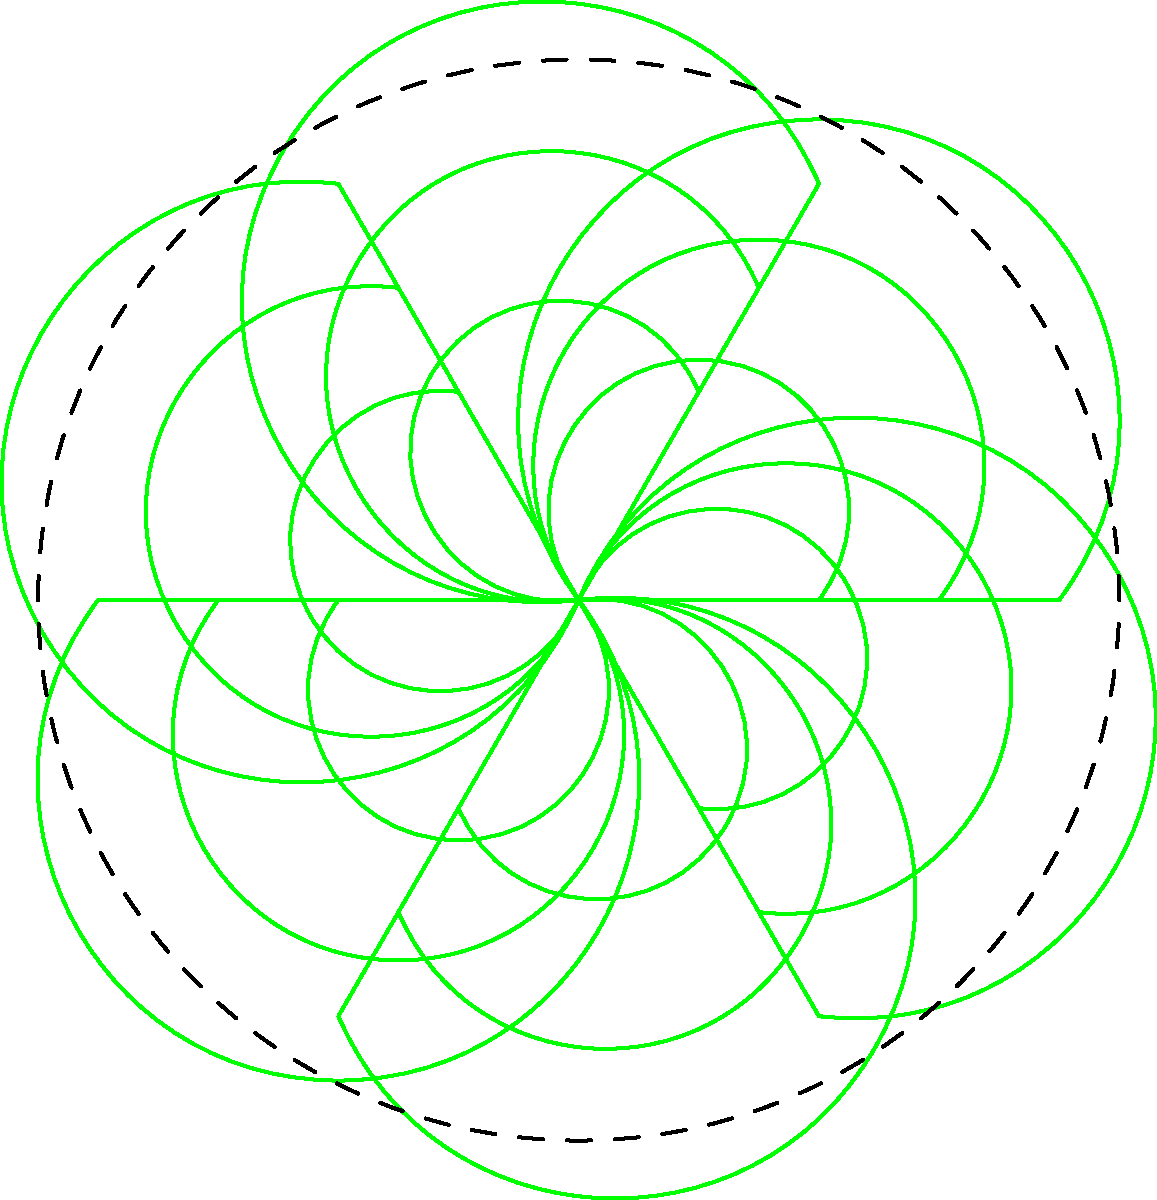In creating a mandala-like pattern for a yoga studio logo using a simple leaf shape, you apply the following transformations: rotation by 60° around the origin, repeated 6 times, and scaling by factors of 1.5 and 2 for each rotated leaf. How many total leaf shapes are in the final pattern? Let's break down the transformations and count the leaf shapes step-by-step:

1. Initial rotation:
   - The leaf shape is rotated 60° around the origin, repeated 6 times.
   - This creates 6 leaf shapes in the innermost ring.

2. Scaling for each rotated leaf:
   - For each of the 6 rotated leaves, two additional scaled versions are created:
     a) Scaled by a factor of 1.5
     b) Scaled by a factor of 2
   - This means for each of the 6 rotated leaves, we have 2 additional leaves.

3. Counting the total leaves:
   - Inner ring (original size): 6 leaves
   - Middle ring (scaled by 1.5): 6 leaves
   - Outer ring (scaled by 2): 6 leaves

4. Total count:
   - Sum of all leaves: 6 + 6 + 6 = 18 leaves

Therefore, the final mandala-like pattern contains 18 leaf shapes in total.
Answer: 18 leaf shapes 